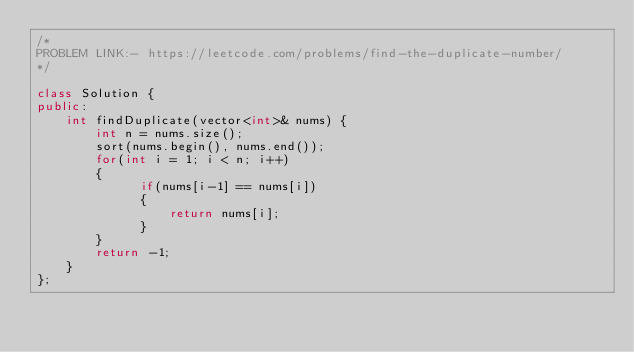<code> <loc_0><loc_0><loc_500><loc_500><_C++_>/*
PROBLEM LINK:- https://leetcode.com/problems/find-the-duplicate-number/
*/

class Solution {
public:
    int findDuplicate(vector<int>& nums) {
        int n = nums.size();
        sort(nums.begin(), nums.end());
        for(int i = 1; i < n; i++)
        {
              if(nums[i-1] == nums[i])  
              {
                  return nums[i];
              }
        }
        return -1;
    }
};
</code> 